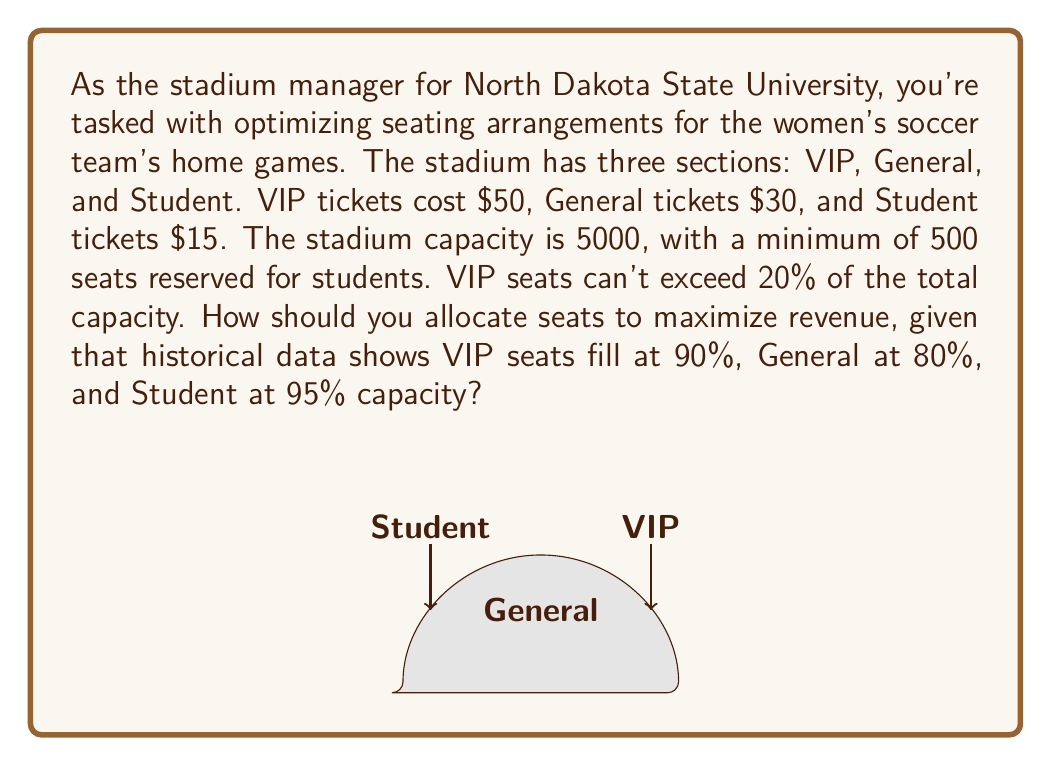Teach me how to tackle this problem. Let's approach this step-by-step using linear programming:

1) Define variables:
   $x$ = number of VIP seats
   $y$ = number of General seats
   $z$ = number of Student seats

2) Objective function (maximize revenue):
   $\text{Max } R = 50(0.9x) + 30(0.8y) + 15(0.95z)$

3) Constraints:
   a) Total capacity: $x + y + z \leq 5000$
   b) Student minimum: $z \geq 500$
   c) VIP maximum: $x \leq 0.2(5000) = 1000$
   d) Non-negativity: $x, y, z \geq 0$

4) Simplify the objective function:
   $\text{Max } R = 45x + 24y + 14.25z$

5) Solve using the simplex method or linear programming software.

6) The optimal solution is:
   $x = 1000$ (VIP seats)
   $y = 3500$ (General seats)
   $z = 500$ (Student seats)

7) Calculate the maximum revenue:
   $R = 45(1000) + 24(3500) + 14.25(500)$
   $R = 45000 + 84000 + 7125 = 136125$

Therefore, to maximize revenue, allocate 1000 seats to VIP, 3500 to General, and 500 to Student sections.
Answer: $136,125 